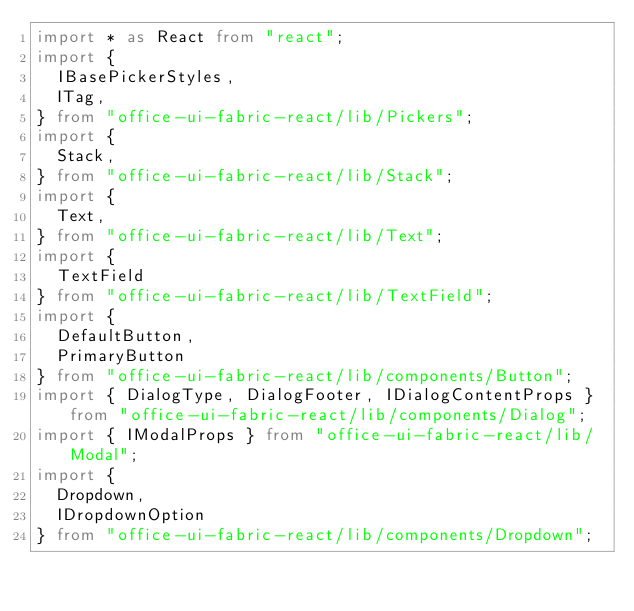Convert code to text. <code><loc_0><loc_0><loc_500><loc_500><_TypeScript_>import * as React from "react";
import {
  IBasePickerStyles,
  ITag,
} from "office-ui-fabric-react/lib/Pickers";
import {
  Stack,
} from "office-ui-fabric-react/lib/Stack";
import {
  Text,
} from "office-ui-fabric-react/lib/Text";
import {
  TextField
} from "office-ui-fabric-react/lib/TextField";
import {
  DefaultButton,
  PrimaryButton
} from "office-ui-fabric-react/lib/components/Button";
import { DialogType, DialogFooter, IDialogContentProps } from "office-ui-fabric-react/lib/components/Dialog";
import { IModalProps } from "office-ui-fabric-react/lib/Modal";
import {
  Dropdown,
  IDropdownOption
} from "office-ui-fabric-react/lib/components/Dropdown";</code> 